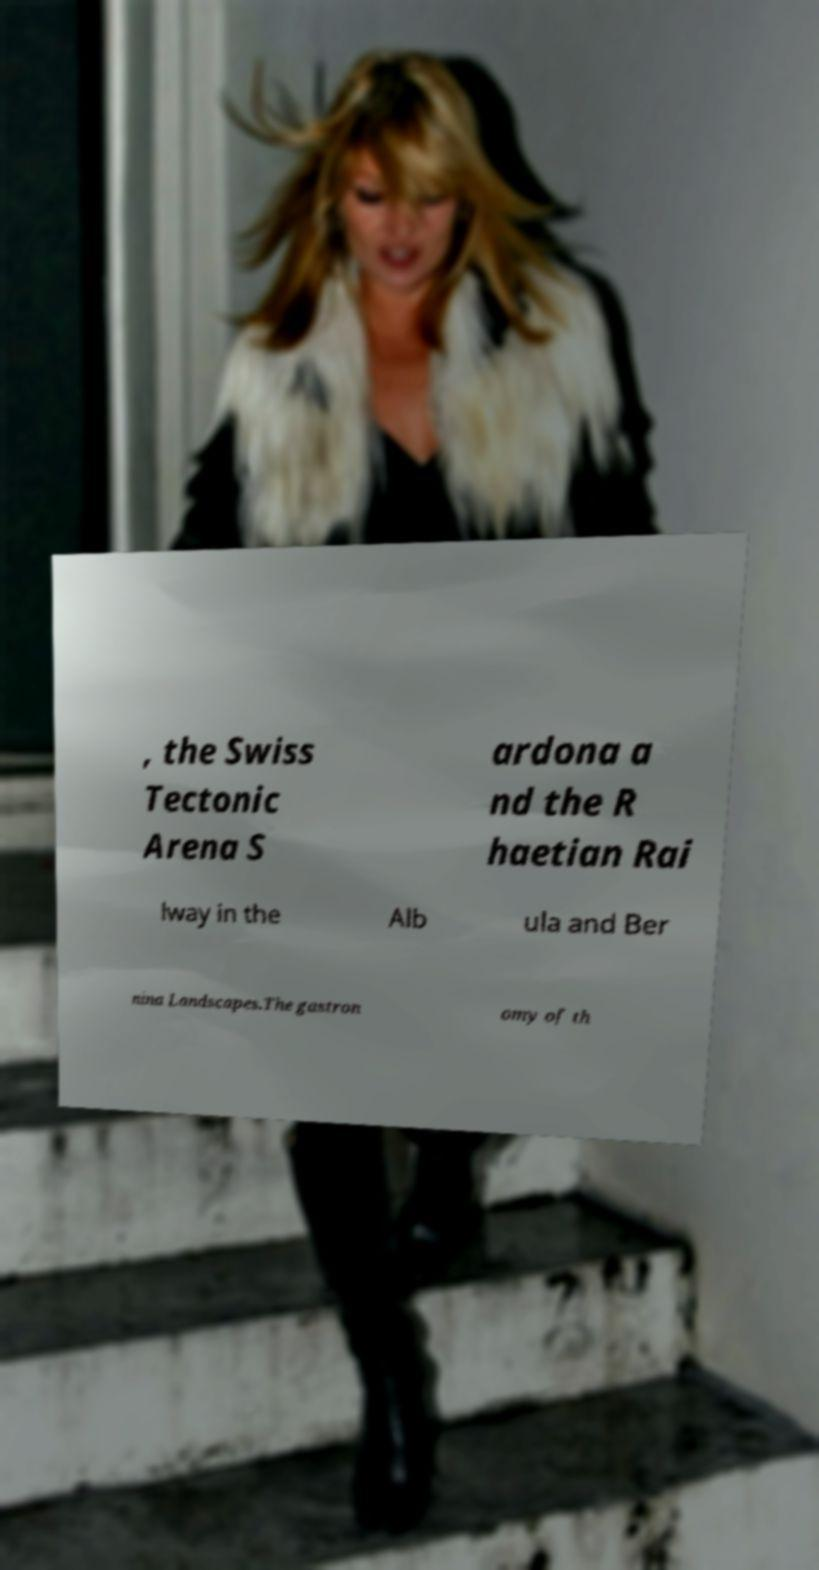For documentation purposes, I need the text within this image transcribed. Could you provide that? , the Swiss Tectonic Arena S ardona a nd the R haetian Rai lway in the Alb ula and Ber nina Landscapes.The gastron omy of th 